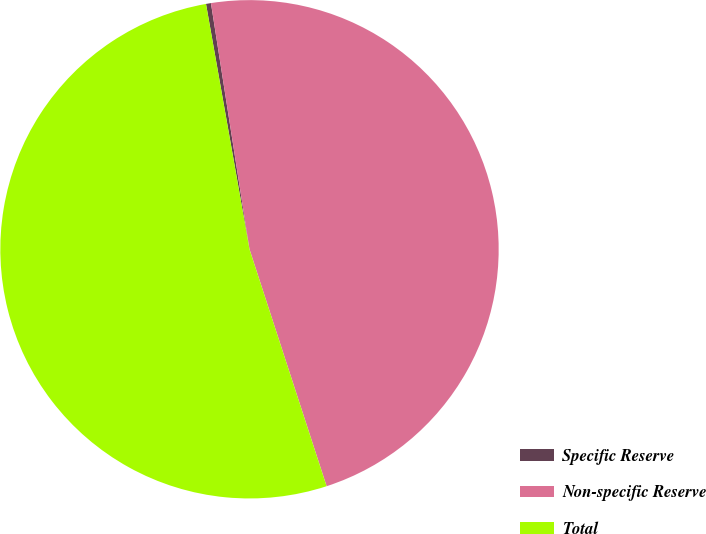Convert chart. <chart><loc_0><loc_0><loc_500><loc_500><pie_chart><fcel>Specific Reserve<fcel>Non-specific Reserve<fcel>Total<nl><fcel>0.32%<fcel>47.47%<fcel>52.22%<nl></chart> 